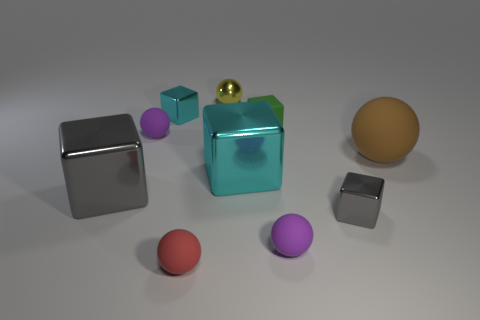Subtract all large cubes. How many cubes are left? 3 Subtract 3 cubes. How many cubes are left? 2 Subtract all purple balls. How many balls are left? 3 Add 3 tiny red matte spheres. How many tiny red matte spheres are left? 4 Add 3 tiny gray blocks. How many tiny gray blocks exist? 4 Subtract 0 brown cylinders. How many objects are left? 10 Subtract all green balls. Subtract all green cubes. How many balls are left? 5 Subtract all brown spheres. How many purple blocks are left? 0 Subtract all tiny green rubber things. Subtract all green rubber spheres. How many objects are left? 9 